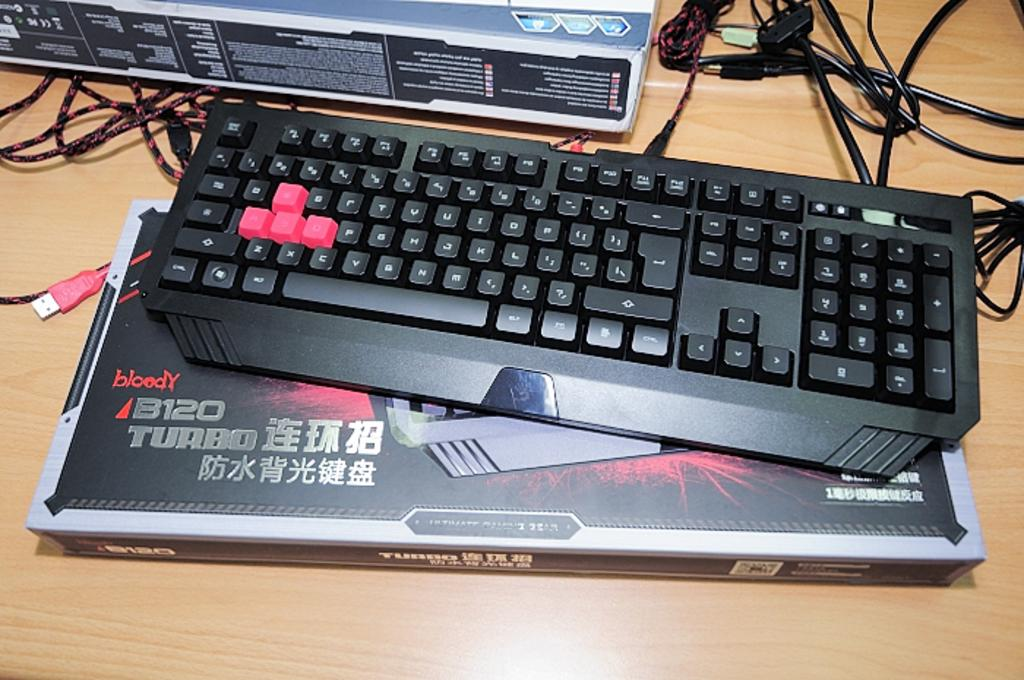<image>
Offer a succinct explanation of the picture presented. a black keyboard on display atop its box reading 8120 Turbo 